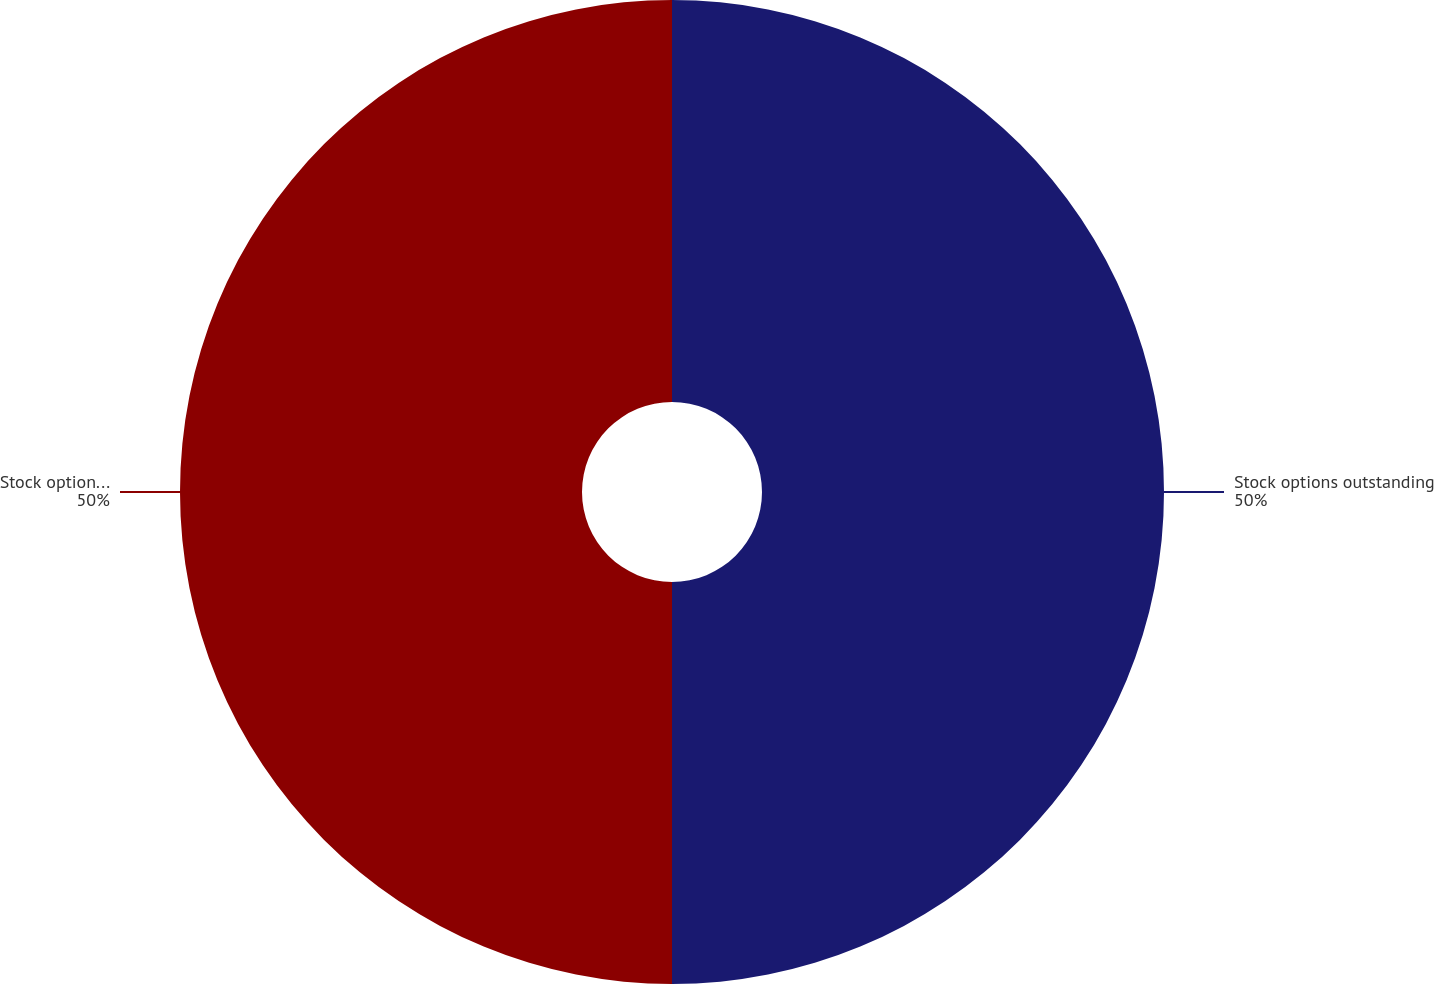<chart> <loc_0><loc_0><loc_500><loc_500><pie_chart><fcel>Stock options outstanding<fcel>Stock options exercisable<nl><fcel>50.0%<fcel>50.0%<nl></chart> 